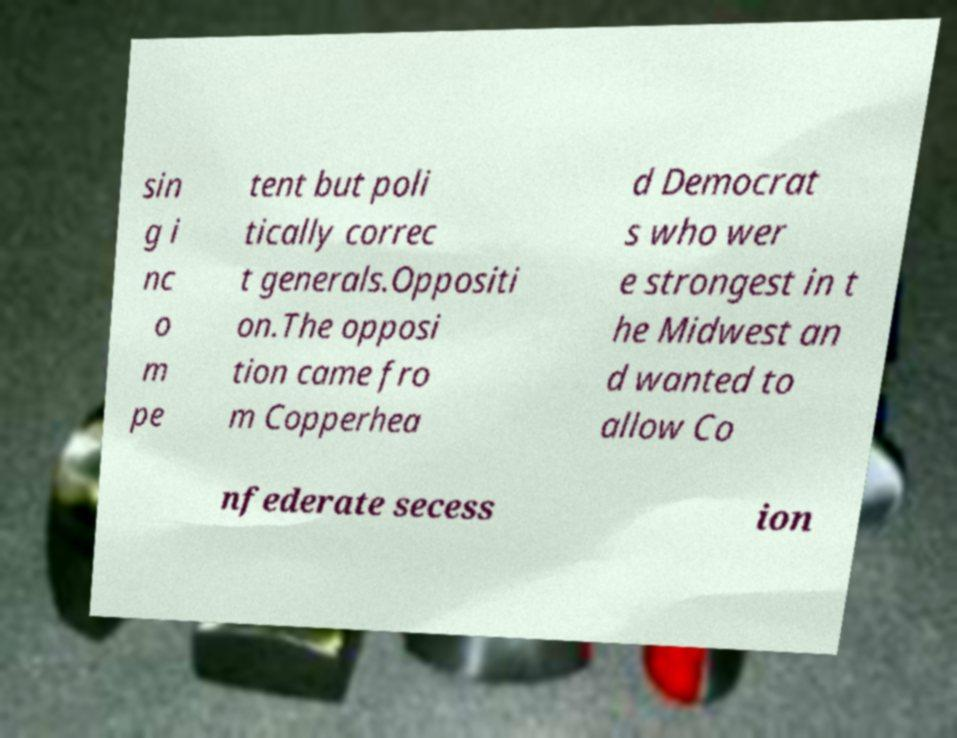Could you extract and type out the text from this image? sin g i nc o m pe tent but poli tically correc t generals.Oppositi on.The opposi tion came fro m Copperhea d Democrat s who wer e strongest in t he Midwest an d wanted to allow Co nfederate secess ion 